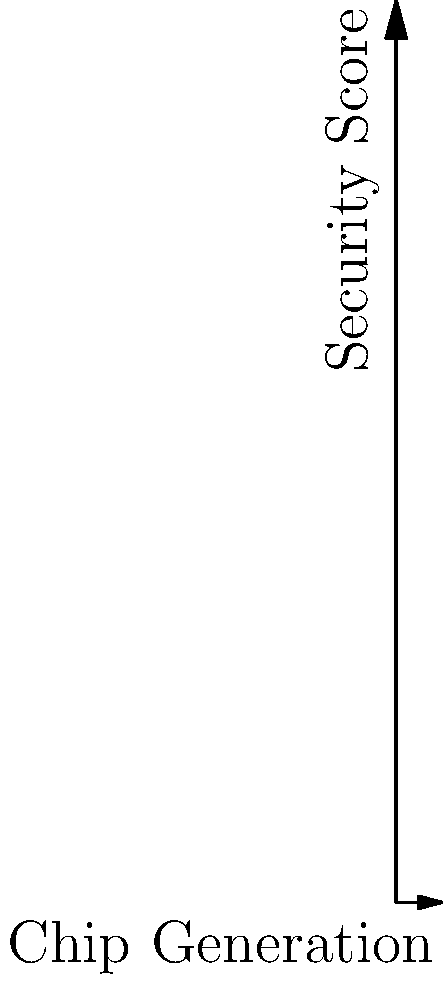Based on the graph showing security scores for three different biometric chip designs across four generations, which design consistently outperforms the others in terms of security, and by what average margin does it surpass the second-best design? To answer this question, we need to follow these steps:

1. Identify the best-performing design:
   Looking at the graph, we can see that Design A (blue line) consistently has the highest security score across all four generations.

2. Identify the second-best design:
   Design B (red line) is consistently the second-best performer.

3. Calculate the difference between Design A and Design B for each generation:
   Generation 1: $75 - 70 = 5$
   Generation 2: $85 - 80 = 5$
   Generation 3: $90 - 88 = 2$
   Generation 4: $95 - 92 = 3$

4. Calculate the average of these differences:
   $\frac{5 + 5 + 2 + 3}{4} = \frac{15}{4} = 3.75$

Therefore, Design A consistently outperforms the others, and it surpasses the second-best design (Design B) by an average margin of 3.75 points.
Answer: Design A, by 3.75 points 